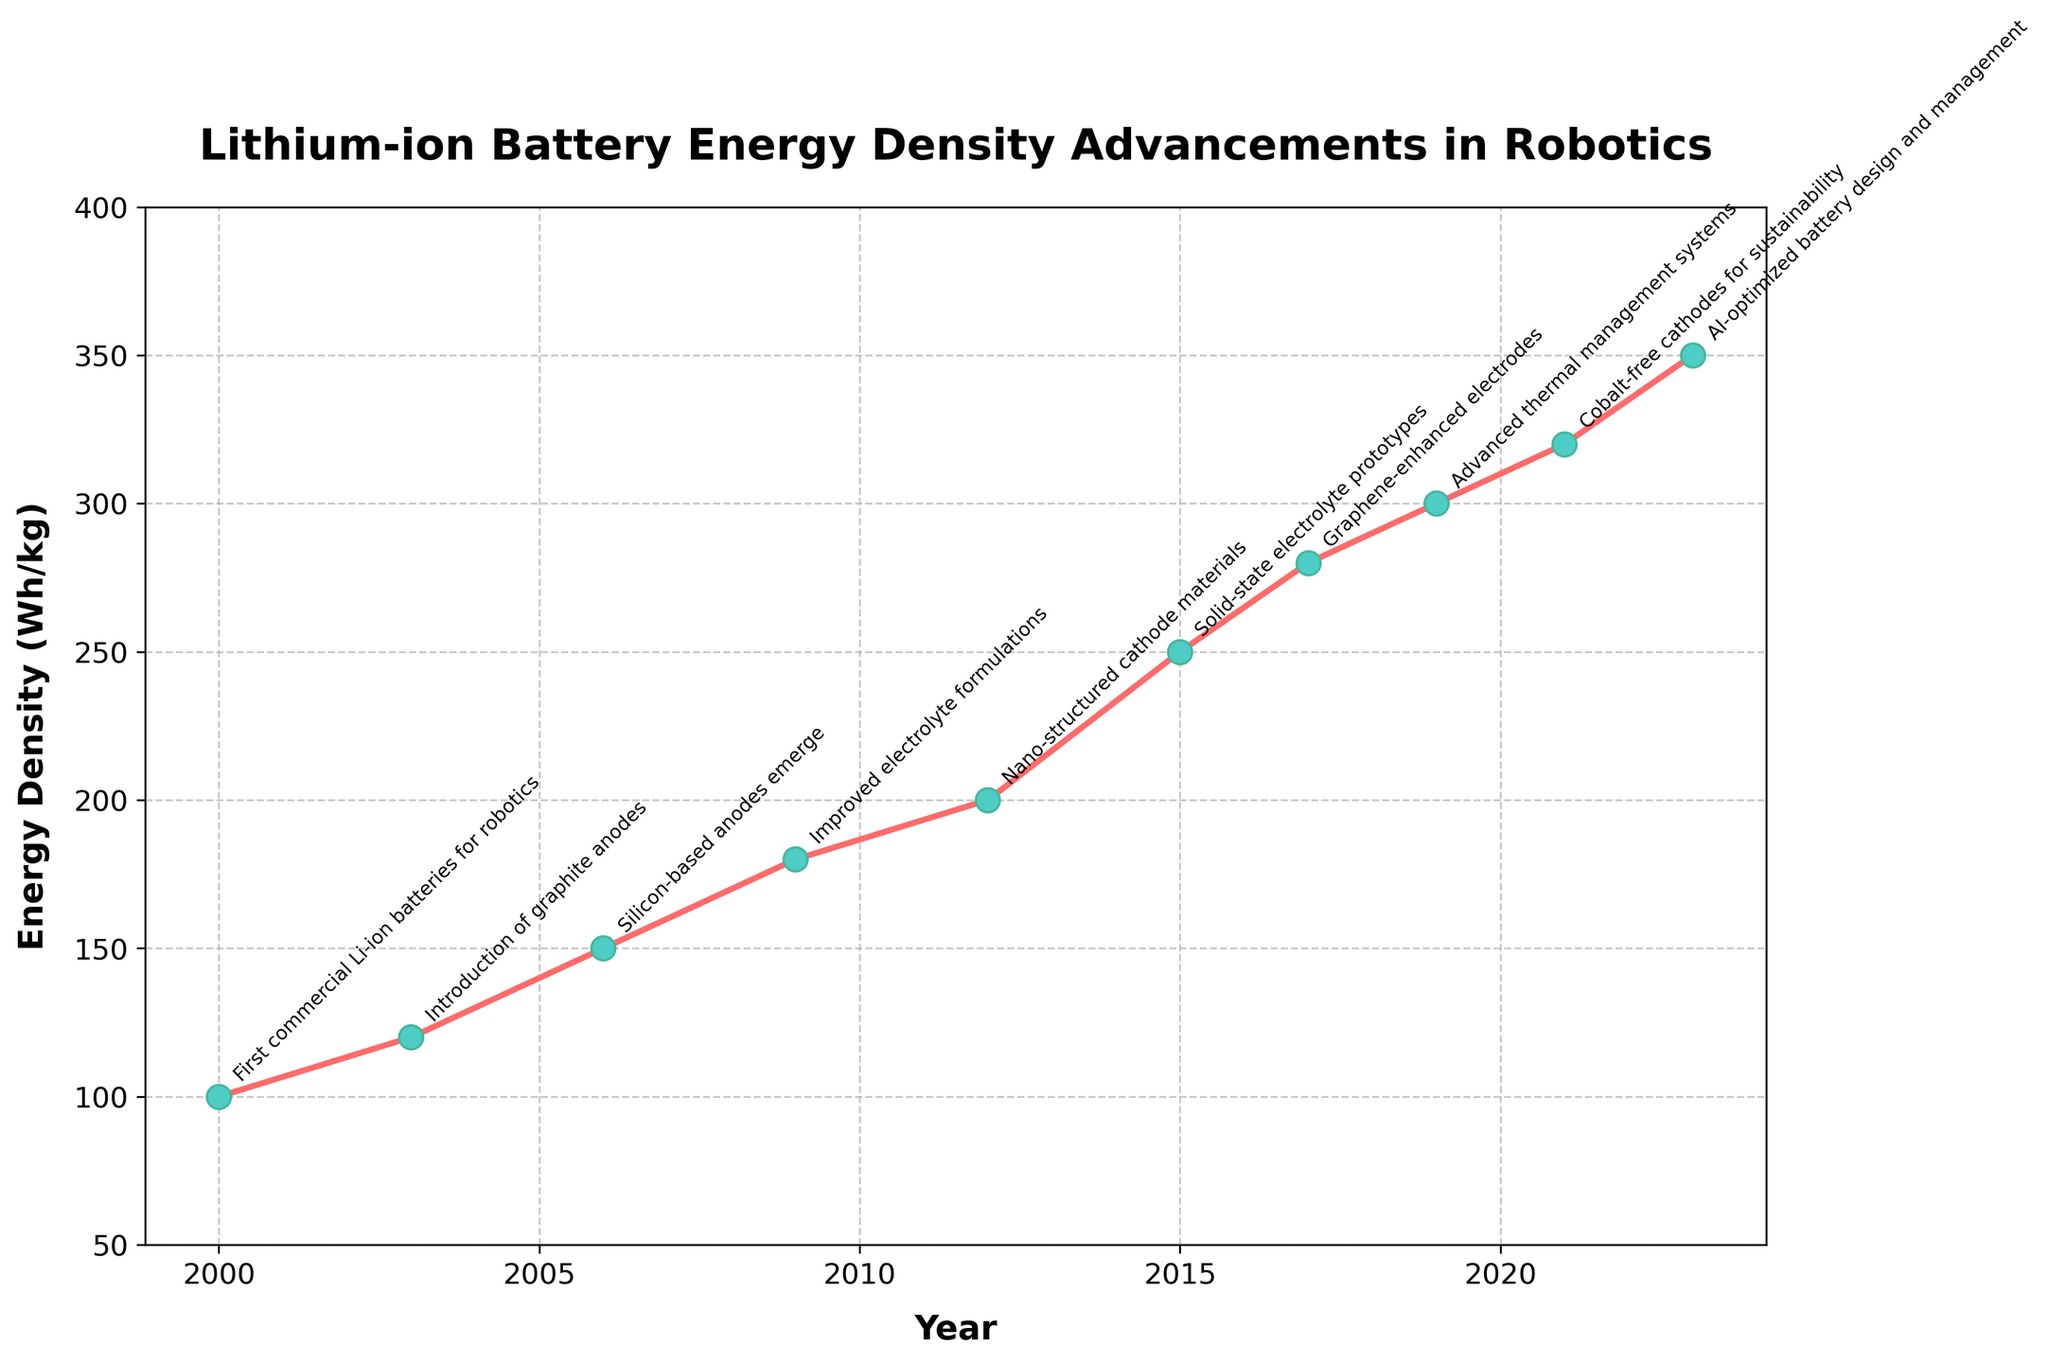what is the average increase in energy density per year between 2000 and 2023? First, find the total increase in energy density from 2000 (100 Wh/kg) to 2023 (350 Wh/kg). The difference is 350 - 100 = 250 Wh/kg. Next, divide this increase by the number of years, which is 2023 - 2000 = 23 years. The average increase is 250/23 ≈ 10.87 Wh/kg per year.
Answer: 10.87 Which year had the highest increase in energy density compared to the previous year? Compare the differences in energy density between each consecutive pair of years. The differences are: (2003-2000)=20, (2006-2003)=30, (2009-2006)=30, (2012-2009)=20, (2015-2012)=50, (2017-2015)=30, (2019-2017)=20, (2021-2019)=20, (2023-2021)=30. The year with the highest difference is 2015 with a 50 Wh/kg increase.
Answer: 2015 What is the overall trend of the energy density from 2000 to 2023? Observing the graph from 2000 to 2023, the energy density of lithium-ion batteries has shown a consistent upward trend. Starting at 100 Wh/kg in 2000 and reaching 350 Wh/kg in 2023, the graph consistently rises with time.
Answer: Upward trend Which notable advancement corresponds to the energy density of 280 Wh/kg? By examining the points and annotations on the graph, we see that the energy density of 280 Wh/kg in 2017 corresponds to the advancement of graphene-enhanced electrodes.
Answer: Graphene-enhanced electrodes What was the energy density improvement between 2015 and 2019? The energy density in 2015 was 250 Wh/kg, and in 2019 it was 300 Wh/kg. The improvement is calculated as 300 - 250 = 50 Wh/kg.
Answer: 50 How does the energy density in 2023 compare to that of 2006? The energy density in 2023 is 350 Wh/kg, and in 2006 it was 150 Wh/kg. Comparing these values, we see that 350 Wh/kg > 150 Wh/kg, indicating a significant improvement over time.
Answer: Higher What is the visual appearance of the marker used for data points on the plot? The data points on the plot are marked with circular markers that have a red color, green faces, and slightly darker green edges.
Answer: Circular, red and green markers What is the energy density associated with the nano-structured cathode materials advancement? By looking at the annotations on the graph, the nano-structured cathode materials advancement corresponds to the energy density of 200 Wh/kg, which occurred in the year 2012.
Answer: 200 Wh/kg Is there any year between 2000 and 2023 where the energy density decreased? By examining the graph, the energy density consistently increases from 2000 to 2023 without any year showing a decrease.
Answer: No 